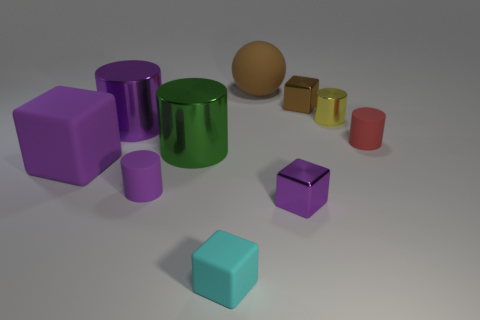There is a purple cube that is on the left side of the small purple shiny block; are there any tiny brown cubes left of it?
Your response must be concise. No. There is a small cylinder behind the red cylinder; what is its material?
Offer a terse response. Metal. Is the material of the big thing behind the brown metal object the same as the block that is behind the large block?
Provide a succinct answer. No. Are there the same number of rubber cylinders that are behind the small red rubber object and blocks that are behind the tiny cyan rubber thing?
Ensure brevity in your answer.  No. What number of yellow cylinders have the same material as the small purple block?
Provide a succinct answer. 1. What shape is the tiny metal thing that is the same color as the sphere?
Offer a terse response. Cube. There is a shiny cylinder that is to the right of the tiny brown metallic thing that is behind the tiny yellow cylinder; what size is it?
Offer a terse response. Small. There is a brown object that is in front of the matte sphere; does it have the same shape as the small purple matte object that is on the left side of the tiny red thing?
Offer a terse response. No. Is the number of green shiny cylinders that are in front of the brown rubber thing the same as the number of tiny cylinders?
Make the answer very short. No. There is another rubber object that is the same shape as the cyan thing; what color is it?
Your answer should be compact. Purple. 